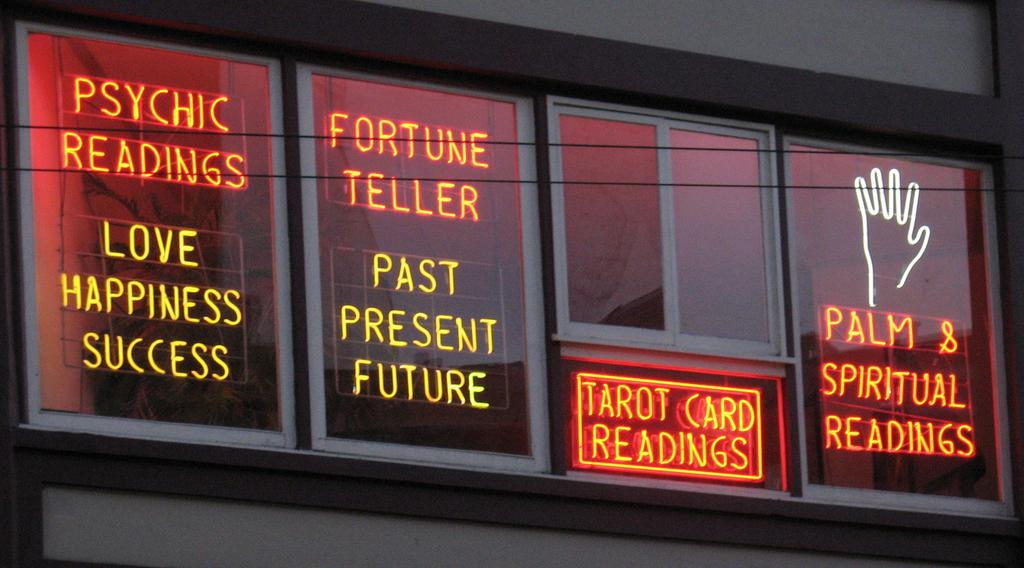<image>
Relay a brief, clear account of the picture shown. Neon lights in a window about Psychic readings and their offerings of fortune and palm readings. 